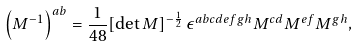Convert formula to latex. <formula><loc_0><loc_0><loc_500><loc_500>\left ( M ^ { - 1 } \right ) ^ { a b } = \frac { 1 } { 4 8 } [ \det { M } ] ^ { - \frac { 1 } { 2 } } \, \epsilon ^ { a b c d e f g h } M ^ { c d } M ^ { e f } M ^ { g h } ,</formula> 